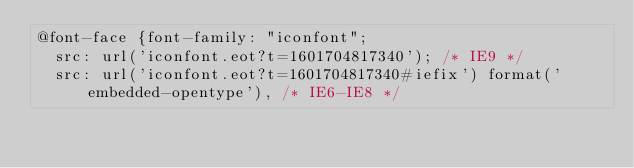<code> <loc_0><loc_0><loc_500><loc_500><_CSS_>@font-face {font-family: "iconfont";
  src: url('iconfont.eot?t=1601704817340'); /* IE9 */
  src: url('iconfont.eot?t=1601704817340#iefix') format('embedded-opentype'), /* IE6-IE8 */</code> 